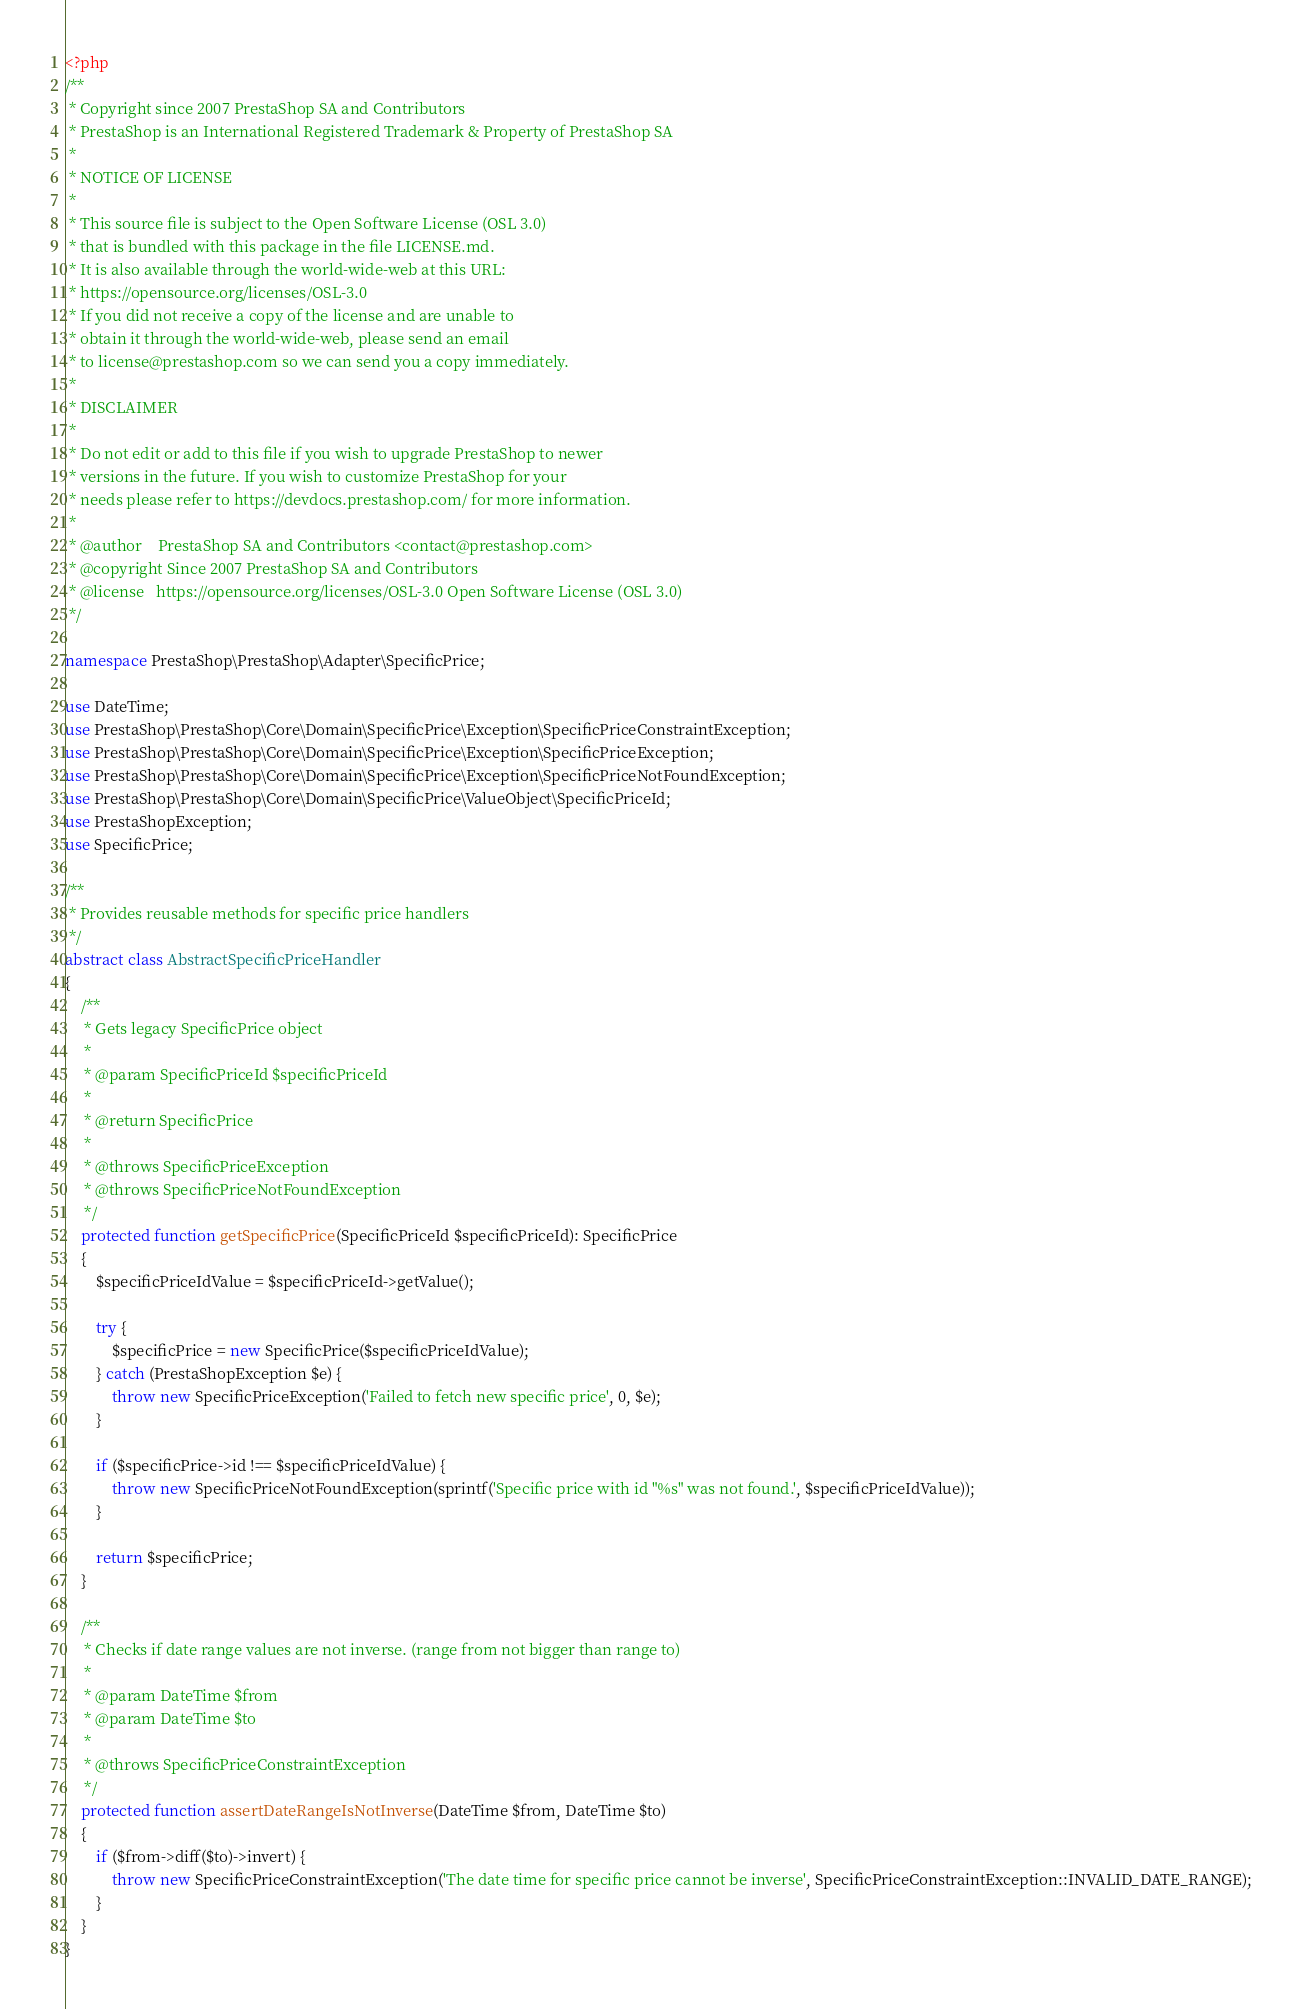<code> <loc_0><loc_0><loc_500><loc_500><_PHP_><?php
/**
 * Copyright since 2007 PrestaShop SA and Contributors
 * PrestaShop is an International Registered Trademark & Property of PrestaShop SA
 *
 * NOTICE OF LICENSE
 *
 * This source file is subject to the Open Software License (OSL 3.0)
 * that is bundled with this package in the file LICENSE.md.
 * It is also available through the world-wide-web at this URL:
 * https://opensource.org/licenses/OSL-3.0
 * If you did not receive a copy of the license and are unable to
 * obtain it through the world-wide-web, please send an email
 * to license@prestashop.com so we can send you a copy immediately.
 *
 * DISCLAIMER
 *
 * Do not edit or add to this file if you wish to upgrade PrestaShop to newer
 * versions in the future. If you wish to customize PrestaShop for your
 * needs please refer to https://devdocs.prestashop.com/ for more information.
 *
 * @author    PrestaShop SA and Contributors <contact@prestashop.com>
 * @copyright Since 2007 PrestaShop SA and Contributors
 * @license   https://opensource.org/licenses/OSL-3.0 Open Software License (OSL 3.0)
 */

namespace PrestaShop\PrestaShop\Adapter\SpecificPrice;

use DateTime;
use PrestaShop\PrestaShop\Core\Domain\SpecificPrice\Exception\SpecificPriceConstraintException;
use PrestaShop\PrestaShop\Core\Domain\SpecificPrice\Exception\SpecificPriceException;
use PrestaShop\PrestaShop\Core\Domain\SpecificPrice\Exception\SpecificPriceNotFoundException;
use PrestaShop\PrestaShop\Core\Domain\SpecificPrice\ValueObject\SpecificPriceId;
use PrestaShopException;
use SpecificPrice;

/**
 * Provides reusable methods for specific price handlers
 */
abstract class AbstractSpecificPriceHandler
{
    /**
     * Gets legacy SpecificPrice object
     *
     * @param SpecificPriceId $specificPriceId
     *
     * @return SpecificPrice
     *
     * @throws SpecificPriceException
     * @throws SpecificPriceNotFoundException
     */
    protected function getSpecificPrice(SpecificPriceId $specificPriceId): SpecificPrice
    {
        $specificPriceIdValue = $specificPriceId->getValue();

        try {
            $specificPrice = new SpecificPrice($specificPriceIdValue);
        } catch (PrestaShopException $e) {
            throw new SpecificPriceException('Failed to fetch new specific price', 0, $e);
        }

        if ($specificPrice->id !== $specificPriceIdValue) {
            throw new SpecificPriceNotFoundException(sprintf('Specific price with id "%s" was not found.', $specificPriceIdValue));
        }

        return $specificPrice;
    }

    /**
     * Checks if date range values are not inverse. (range from not bigger than range to)
     *
     * @param DateTime $from
     * @param DateTime $to
     *
     * @throws SpecificPriceConstraintException
     */
    protected function assertDateRangeIsNotInverse(DateTime $from, DateTime $to)
    {
        if ($from->diff($to)->invert) {
            throw new SpecificPriceConstraintException('The date time for specific price cannot be inverse', SpecificPriceConstraintException::INVALID_DATE_RANGE);
        }
    }
}
</code> 